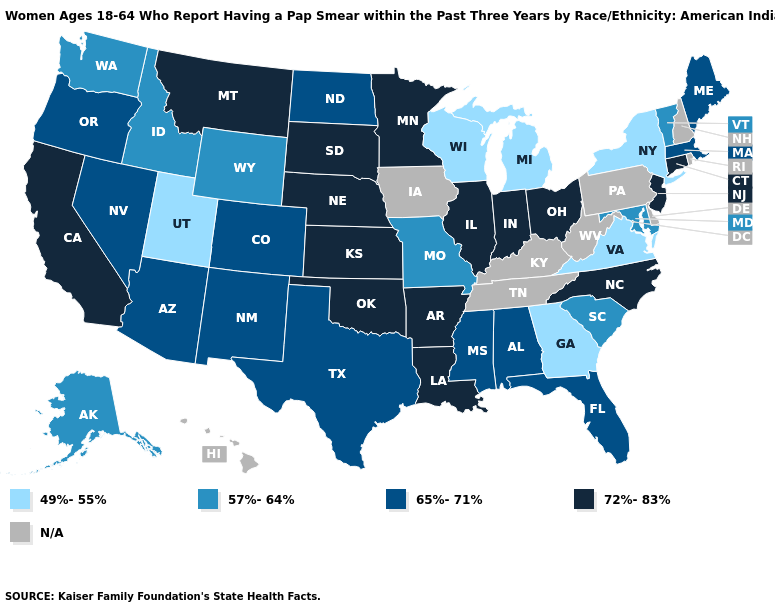Name the states that have a value in the range N/A?
Write a very short answer. Delaware, Hawaii, Iowa, Kentucky, New Hampshire, Pennsylvania, Rhode Island, Tennessee, West Virginia. What is the value of New Mexico?
Give a very brief answer. 65%-71%. What is the value of Nebraska?
Answer briefly. 72%-83%. What is the highest value in the USA?
Write a very short answer. 72%-83%. What is the value of Maryland?
Short answer required. 57%-64%. What is the lowest value in the USA?
Give a very brief answer. 49%-55%. What is the value of Nevada?
Concise answer only. 65%-71%. What is the value of Idaho?
Answer briefly. 57%-64%. Name the states that have a value in the range 57%-64%?
Give a very brief answer. Alaska, Idaho, Maryland, Missouri, South Carolina, Vermont, Washington, Wyoming. Name the states that have a value in the range 65%-71%?
Write a very short answer. Alabama, Arizona, Colorado, Florida, Maine, Massachusetts, Mississippi, Nevada, New Mexico, North Dakota, Oregon, Texas. Name the states that have a value in the range N/A?
Write a very short answer. Delaware, Hawaii, Iowa, Kentucky, New Hampshire, Pennsylvania, Rhode Island, Tennessee, West Virginia. What is the highest value in states that border Kentucky?
Quick response, please. 72%-83%. What is the value of South Dakota?
Concise answer only. 72%-83%. What is the value of Indiana?
Quick response, please. 72%-83%. 